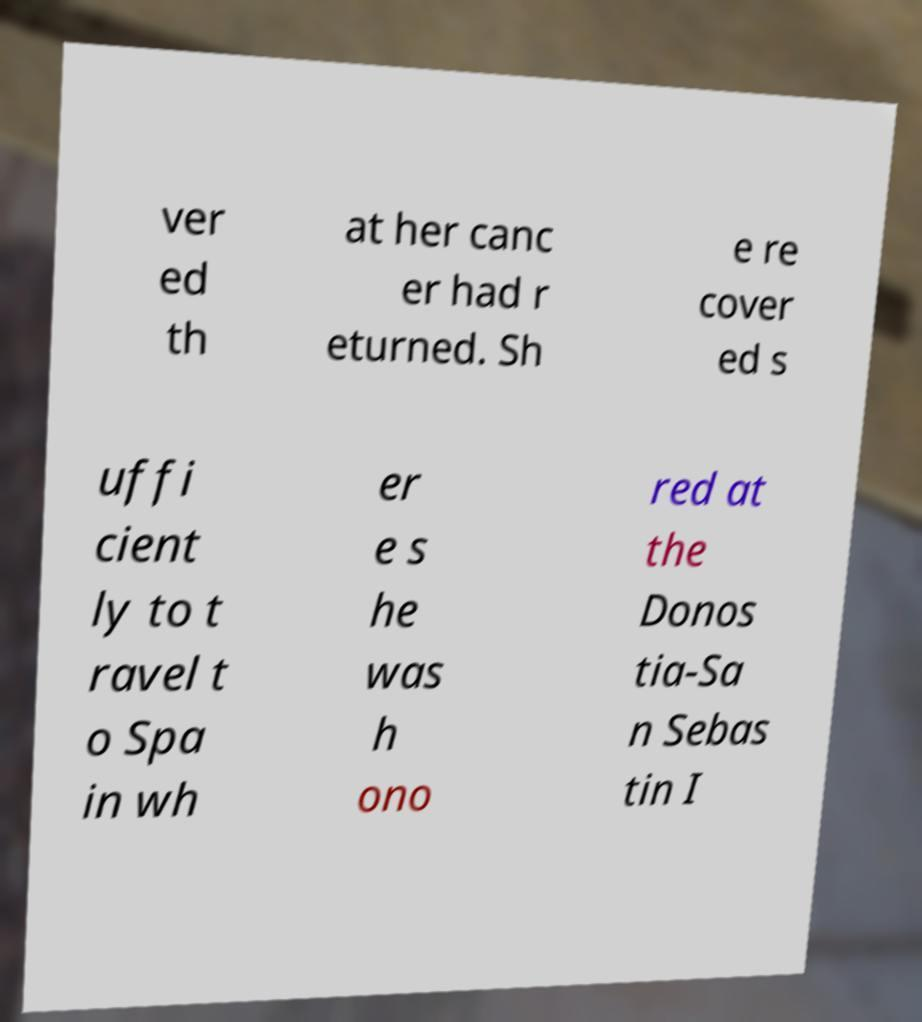Please identify and transcribe the text found in this image. ver ed th at her canc er had r eturned. Sh e re cover ed s uffi cient ly to t ravel t o Spa in wh er e s he was h ono red at the Donos tia-Sa n Sebas tin I 